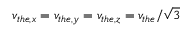<formula> <loc_0><loc_0><loc_500><loc_500>v _ { t h e , x } = v _ { t h e , y } = v _ { t h e , z } = v _ { t h e } / \sqrt { 3 }</formula> 